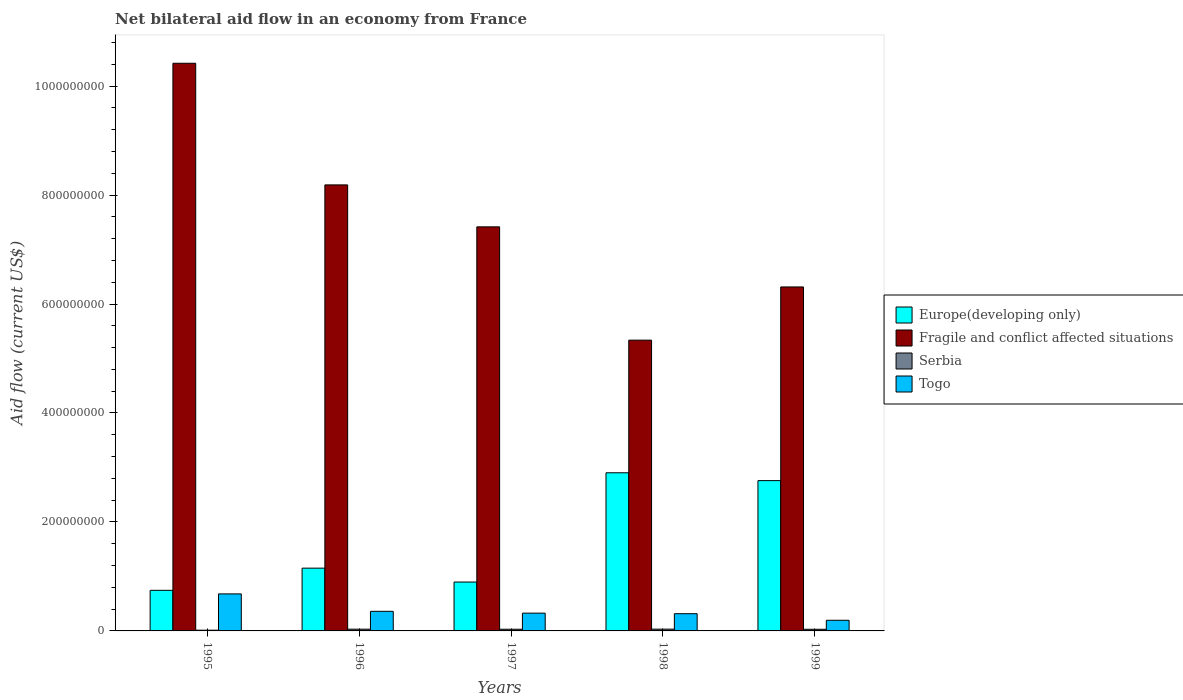How many different coloured bars are there?
Provide a short and direct response. 4. How many groups of bars are there?
Your answer should be compact. 5. Are the number of bars per tick equal to the number of legend labels?
Your answer should be very brief. Yes. Are the number of bars on each tick of the X-axis equal?
Offer a terse response. Yes. How many bars are there on the 3rd tick from the right?
Make the answer very short. 4. What is the net bilateral aid flow in Europe(developing only) in 1998?
Keep it short and to the point. 2.90e+08. Across all years, what is the maximum net bilateral aid flow in Togo?
Provide a succinct answer. 6.80e+07. Across all years, what is the minimum net bilateral aid flow in Togo?
Provide a succinct answer. 1.95e+07. In which year was the net bilateral aid flow in Fragile and conflict affected situations maximum?
Give a very brief answer. 1995. What is the total net bilateral aid flow in Fragile and conflict affected situations in the graph?
Make the answer very short. 3.77e+09. What is the difference between the net bilateral aid flow in Serbia in 1995 and that in 1996?
Make the answer very short. -1.86e+06. What is the difference between the net bilateral aid flow in Togo in 1997 and the net bilateral aid flow in Serbia in 1995?
Provide a short and direct response. 3.13e+07. What is the average net bilateral aid flow in Fragile and conflict affected situations per year?
Offer a terse response. 7.53e+08. In the year 1998, what is the difference between the net bilateral aid flow in Serbia and net bilateral aid flow in Togo?
Offer a terse response. -2.84e+07. What is the ratio of the net bilateral aid flow in Fragile and conflict affected situations in 1996 to that in 1997?
Give a very brief answer. 1.1. What is the difference between the highest and the second highest net bilateral aid flow in Fragile and conflict affected situations?
Your answer should be very brief. 2.23e+08. What is the difference between the highest and the lowest net bilateral aid flow in Serbia?
Offer a terse response. 1.91e+06. Is the sum of the net bilateral aid flow in Europe(developing only) in 1997 and 1999 greater than the maximum net bilateral aid flow in Serbia across all years?
Your response must be concise. Yes. Is it the case that in every year, the sum of the net bilateral aid flow in Fragile and conflict affected situations and net bilateral aid flow in Togo is greater than the sum of net bilateral aid flow in Europe(developing only) and net bilateral aid flow in Serbia?
Keep it short and to the point. Yes. What does the 3rd bar from the left in 1999 represents?
Keep it short and to the point. Serbia. What does the 4th bar from the right in 1999 represents?
Provide a short and direct response. Europe(developing only). Are all the bars in the graph horizontal?
Give a very brief answer. No. What is the difference between two consecutive major ticks on the Y-axis?
Give a very brief answer. 2.00e+08. How are the legend labels stacked?
Ensure brevity in your answer.  Vertical. What is the title of the graph?
Provide a short and direct response. Net bilateral aid flow in an economy from France. What is the Aid flow (current US$) of Europe(developing only) in 1995?
Your answer should be very brief. 7.45e+07. What is the Aid flow (current US$) in Fragile and conflict affected situations in 1995?
Keep it short and to the point. 1.04e+09. What is the Aid flow (current US$) of Serbia in 1995?
Keep it short and to the point. 1.33e+06. What is the Aid flow (current US$) of Togo in 1995?
Make the answer very short. 6.80e+07. What is the Aid flow (current US$) in Europe(developing only) in 1996?
Make the answer very short. 1.15e+08. What is the Aid flow (current US$) of Fragile and conflict affected situations in 1996?
Give a very brief answer. 8.19e+08. What is the Aid flow (current US$) of Serbia in 1996?
Ensure brevity in your answer.  3.19e+06. What is the Aid flow (current US$) in Togo in 1996?
Provide a succinct answer. 3.60e+07. What is the Aid flow (current US$) of Europe(developing only) in 1997?
Your answer should be compact. 8.97e+07. What is the Aid flow (current US$) in Fragile and conflict affected situations in 1997?
Provide a succinct answer. 7.42e+08. What is the Aid flow (current US$) of Serbia in 1997?
Give a very brief answer. 3.08e+06. What is the Aid flow (current US$) of Togo in 1997?
Give a very brief answer. 3.26e+07. What is the Aid flow (current US$) in Europe(developing only) in 1998?
Your answer should be compact. 2.90e+08. What is the Aid flow (current US$) of Fragile and conflict affected situations in 1998?
Give a very brief answer. 5.34e+08. What is the Aid flow (current US$) of Serbia in 1998?
Offer a terse response. 3.24e+06. What is the Aid flow (current US$) of Togo in 1998?
Your answer should be compact. 3.16e+07. What is the Aid flow (current US$) in Europe(developing only) in 1999?
Give a very brief answer. 2.76e+08. What is the Aid flow (current US$) in Fragile and conflict affected situations in 1999?
Offer a very short reply. 6.31e+08. What is the Aid flow (current US$) in Serbia in 1999?
Offer a terse response. 3.01e+06. What is the Aid flow (current US$) in Togo in 1999?
Offer a very short reply. 1.95e+07. Across all years, what is the maximum Aid flow (current US$) of Europe(developing only)?
Your answer should be very brief. 2.90e+08. Across all years, what is the maximum Aid flow (current US$) of Fragile and conflict affected situations?
Make the answer very short. 1.04e+09. Across all years, what is the maximum Aid flow (current US$) of Serbia?
Keep it short and to the point. 3.24e+06. Across all years, what is the maximum Aid flow (current US$) in Togo?
Provide a short and direct response. 6.80e+07. Across all years, what is the minimum Aid flow (current US$) in Europe(developing only)?
Offer a terse response. 7.45e+07. Across all years, what is the minimum Aid flow (current US$) in Fragile and conflict affected situations?
Make the answer very short. 5.34e+08. Across all years, what is the minimum Aid flow (current US$) in Serbia?
Offer a very short reply. 1.33e+06. Across all years, what is the minimum Aid flow (current US$) in Togo?
Make the answer very short. 1.95e+07. What is the total Aid flow (current US$) of Europe(developing only) in the graph?
Your answer should be compact. 8.46e+08. What is the total Aid flow (current US$) in Fragile and conflict affected situations in the graph?
Provide a short and direct response. 3.77e+09. What is the total Aid flow (current US$) of Serbia in the graph?
Offer a terse response. 1.38e+07. What is the total Aid flow (current US$) in Togo in the graph?
Your answer should be very brief. 1.88e+08. What is the difference between the Aid flow (current US$) in Europe(developing only) in 1995 and that in 1996?
Your answer should be compact. -4.07e+07. What is the difference between the Aid flow (current US$) in Fragile and conflict affected situations in 1995 and that in 1996?
Your response must be concise. 2.23e+08. What is the difference between the Aid flow (current US$) in Serbia in 1995 and that in 1996?
Keep it short and to the point. -1.86e+06. What is the difference between the Aid flow (current US$) of Togo in 1995 and that in 1996?
Make the answer very short. 3.20e+07. What is the difference between the Aid flow (current US$) in Europe(developing only) in 1995 and that in 1997?
Make the answer very short. -1.52e+07. What is the difference between the Aid flow (current US$) in Fragile and conflict affected situations in 1995 and that in 1997?
Give a very brief answer. 3.00e+08. What is the difference between the Aid flow (current US$) in Serbia in 1995 and that in 1997?
Ensure brevity in your answer.  -1.75e+06. What is the difference between the Aid flow (current US$) in Togo in 1995 and that in 1997?
Ensure brevity in your answer.  3.53e+07. What is the difference between the Aid flow (current US$) in Europe(developing only) in 1995 and that in 1998?
Provide a succinct answer. -2.16e+08. What is the difference between the Aid flow (current US$) of Fragile and conflict affected situations in 1995 and that in 1998?
Offer a very short reply. 5.08e+08. What is the difference between the Aid flow (current US$) of Serbia in 1995 and that in 1998?
Provide a short and direct response. -1.91e+06. What is the difference between the Aid flow (current US$) in Togo in 1995 and that in 1998?
Your answer should be very brief. 3.63e+07. What is the difference between the Aid flow (current US$) of Europe(developing only) in 1995 and that in 1999?
Provide a succinct answer. -2.01e+08. What is the difference between the Aid flow (current US$) in Fragile and conflict affected situations in 1995 and that in 1999?
Offer a terse response. 4.11e+08. What is the difference between the Aid flow (current US$) of Serbia in 1995 and that in 1999?
Ensure brevity in your answer.  -1.68e+06. What is the difference between the Aid flow (current US$) of Togo in 1995 and that in 1999?
Your answer should be very brief. 4.84e+07. What is the difference between the Aid flow (current US$) of Europe(developing only) in 1996 and that in 1997?
Offer a very short reply. 2.55e+07. What is the difference between the Aid flow (current US$) of Fragile and conflict affected situations in 1996 and that in 1997?
Your answer should be compact. 7.70e+07. What is the difference between the Aid flow (current US$) in Togo in 1996 and that in 1997?
Give a very brief answer. 3.35e+06. What is the difference between the Aid flow (current US$) of Europe(developing only) in 1996 and that in 1998?
Ensure brevity in your answer.  -1.75e+08. What is the difference between the Aid flow (current US$) of Fragile and conflict affected situations in 1996 and that in 1998?
Offer a terse response. 2.85e+08. What is the difference between the Aid flow (current US$) of Serbia in 1996 and that in 1998?
Offer a very short reply. -5.00e+04. What is the difference between the Aid flow (current US$) of Togo in 1996 and that in 1998?
Offer a very short reply. 4.36e+06. What is the difference between the Aid flow (current US$) in Europe(developing only) in 1996 and that in 1999?
Keep it short and to the point. -1.61e+08. What is the difference between the Aid flow (current US$) in Fragile and conflict affected situations in 1996 and that in 1999?
Your response must be concise. 1.87e+08. What is the difference between the Aid flow (current US$) in Togo in 1996 and that in 1999?
Make the answer very short. 1.64e+07. What is the difference between the Aid flow (current US$) in Europe(developing only) in 1997 and that in 1998?
Provide a short and direct response. -2.01e+08. What is the difference between the Aid flow (current US$) in Fragile and conflict affected situations in 1997 and that in 1998?
Give a very brief answer. 2.08e+08. What is the difference between the Aid flow (current US$) in Serbia in 1997 and that in 1998?
Provide a short and direct response. -1.60e+05. What is the difference between the Aid flow (current US$) of Togo in 1997 and that in 1998?
Provide a short and direct response. 1.01e+06. What is the difference between the Aid flow (current US$) of Europe(developing only) in 1997 and that in 1999?
Provide a succinct answer. -1.86e+08. What is the difference between the Aid flow (current US$) of Fragile and conflict affected situations in 1997 and that in 1999?
Offer a very short reply. 1.10e+08. What is the difference between the Aid flow (current US$) in Serbia in 1997 and that in 1999?
Offer a very short reply. 7.00e+04. What is the difference between the Aid flow (current US$) in Togo in 1997 and that in 1999?
Make the answer very short. 1.31e+07. What is the difference between the Aid flow (current US$) in Europe(developing only) in 1998 and that in 1999?
Ensure brevity in your answer.  1.44e+07. What is the difference between the Aid flow (current US$) of Fragile and conflict affected situations in 1998 and that in 1999?
Keep it short and to the point. -9.77e+07. What is the difference between the Aid flow (current US$) of Togo in 1998 and that in 1999?
Ensure brevity in your answer.  1.21e+07. What is the difference between the Aid flow (current US$) in Europe(developing only) in 1995 and the Aid flow (current US$) in Fragile and conflict affected situations in 1996?
Your answer should be very brief. -7.44e+08. What is the difference between the Aid flow (current US$) of Europe(developing only) in 1995 and the Aid flow (current US$) of Serbia in 1996?
Provide a short and direct response. 7.13e+07. What is the difference between the Aid flow (current US$) of Europe(developing only) in 1995 and the Aid flow (current US$) of Togo in 1996?
Give a very brief answer. 3.85e+07. What is the difference between the Aid flow (current US$) in Fragile and conflict affected situations in 1995 and the Aid flow (current US$) in Serbia in 1996?
Make the answer very short. 1.04e+09. What is the difference between the Aid flow (current US$) of Fragile and conflict affected situations in 1995 and the Aid flow (current US$) of Togo in 1996?
Offer a very short reply. 1.01e+09. What is the difference between the Aid flow (current US$) of Serbia in 1995 and the Aid flow (current US$) of Togo in 1996?
Your answer should be very brief. -3.46e+07. What is the difference between the Aid flow (current US$) of Europe(developing only) in 1995 and the Aid flow (current US$) of Fragile and conflict affected situations in 1997?
Your answer should be compact. -6.67e+08. What is the difference between the Aid flow (current US$) of Europe(developing only) in 1995 and the Aid flow (current US$) of Serbia in 1997?
Ensure brevity in your answer.  7.14e+07. What is the difference between the Aid flow (current US$) in Europe(developing only) in 1995 and the Aid flow (current US$) in Togo in 1997?
Give a very brief answer. 4.19e+07. What is the difference between the Aid flow (current US$) of Fragile and conflict affected situations in 1995 and the Aid flow (current US$) of Serbia in 1997?
Keep it short and to the point. 1.04e+09. What is the difference between the Aid flow (current US$) in Fragile and conflict affected situations in 1995 and the Aid flow (current US$) in Togo in 1997?
Provide a succinct answer. 1.01e+09. What is the difference between the Aid flow (current US$) in Serbia in 1995 and the Aid flow (current US$) in Togo in 1997?
Provide a succinct answer. -3.13e+07. What is the difference between the Aid flow (current US$) in Europe(developing only) in 1995 and the Aid flow (current US$) in Fragile and conflict affected situations in 1998?
Offer a terse response. -4.59e+08. What is the difference between the Aid flow (current US$) in Europe(developing only) in 1995 and the Aid flow (current US$) in Serbia in 1998?
Your response must be concise. 7.13e+07. What is the difference between the Aid flow (current US$) of Europe(developing only) in 1995 and the Aid flow (current US$) of Togo in 1998?
Make the answer very short. 4.29e+07. What is the difference between the Aid flow (current US$) of Fragile and conflict affected situations in 1995 and the Aid flow (current US$) of Serbia in 1998?
Your answer should be very brief. 1.04e+09. What is the difference between the Aid flow (current US$) of Fragile and conflict affected situations in 1995 and the Aid flow (current US$) of Togo in 1998?
Your answer should be very brief. 1.01e+09. What is the difference between the Aid flow (current US$) in Serbia in 1995 and the Aid flow (current US$) in Togo in 1998?
Make the answer very short. -3.03e+07. What is the difference between the Aid flow (current US$) in Europe(developing only) in 1995 and the Aid flow (current US$) in Fragile and conflict affected situations in 1999?
Give a very brief answer. -5.57e+08. What is the difference between the Aid flow (current US$) in Europe(developing only) in 1995 and the Aid flow (current US$) in Serbia in 1999?
Offer a very short reply. 7.15e+07. What is the difference between the Aid flow (current US$) in Europe(developing only) in 1995 and the Aid flow (current US$) in Togo in 1999?
Offer a very short reply. 5.50e+07. What is the difference between the Aid flow (current US$) in Fragile and conflict affected situations in 1995 and the Aid flow (current US$) in Serbia in 1999?
Provide a succinct answer. 1.04e+09. What is the difference between the Aid flow (current US$) of Fragile and conflict affected situations in 1995 and the Aid flow (current US$) of Togo in 1999?
Offer a terse response. 1.02e+09. What is the difference between the Aid flow (current US$) of Serbia in 1995 and the Aid flow (current US$) of Togo in 1999?
Make the answer very short. -1.82e+07. What is the difference between the Aid flow (current US$) in Europe(developing only) in 1996 and the Aid flow (current US$) in Fragile and conflict affected situations in 1997?
Provide a succinct answer. -6.26e+08. What is the difference between the Aid flow (current US$) of Europe(developing only) in 1996 and the Aid flow (current US$) of Serbia in 1997?
Offer a terse response. 1.12e+08. What is the difference between the Aid flow (current US$) of Europe(developing only) in 1996 and the Aid flow (current US$) of Togo in 1997?
Offer a terse response. 8.26e+07. What is the difference between the Aid flow (current US$) of Fragile and conflict affected situations in 1996 and the Aid flow (current US$) of Serbia in 1997?
Offer a terse response. 8.16e+08. What is the difference between the Aid flow (current US$) of Fragile and conflict affected situations in 1996 and the Aid flow (current US$) of Togo in 1997?
Keep it short and to the point. 7.86e+08. What is the difference between the Aid flow (current US$) of Serbia in 1996 and the Aid flow (current US$) of Togo in 1997?
Offer a terse response. -2.94e+07. What is the difference between the Aid flow (current US$) in Europe(developing only) in 1996 and the Aid flow (current US$) in Fragile and conflict affected situations in 1998?
Your response must be concise. -4.18e+08. What is the difference between the Aid flow (current US$) in Europe(developing only) in 1996 and the Aid flow (current US$) in Serbia in 1998?
Offer a terse response. 1.12e+08. What is the difference between the Aid flow (current US$) in Europe(developing only) in 1996 and the Aid flow (current US$) in Togo in 1998?
Your response must be concise. 8.36e+07. What is the difference between the Aid flow (current US$) of Fragile and conflict affected situations in 1996 and the Aid flow (current US$) of Serbia in 1998?
Your answer should be compact. 8.15e+08. What is the difference between the Aid flow (current US$) of Fragile and conflict affected situations in 1996 and the Aid flow (current US$) of Togo in 1998?
Keep it short and to the point. 7.87e+08. What is the difference between the Aid flow (current US$) of Serbia in 1996 and the Aid flow (current US$) of Togo in 1998?
Your response must be concise. -2.84e+07. What is the difference between the Aid flow (current US$) in Europe(developing only) in 1996 and the Aid flow (current US$) in Fragile and conflict affected situations in 1999?
Offer a terse response. -5.16e+08. What is the difference between the Aid flow (current US$) of Europe(developing only) in 1996 and the Aid flow (current US$) of Serbia in 1999?
Provide a short and direct response. 1.12e+08. What is the difference between the Aid flow (current US$) of Europe(developing only) in 1996 and the Aid flow (current US$) of Togo in 1999?
Your answer should be very brief. 9.57e+07. What is the difference between the Aid flow (current US$) of Fragile and conflict affected situations in 1996 and the Aid flow (current US$) of Serbia in 1999?
Keep it short and to the point. 8.16e+08. What is the difference between the Aid flow (current US$) in Fragile and conflict affected situations in 1996 and the Aid flow (current US$) in Togo in 1999?
Offer a very short reply. 7.99e+08. What is the difference between the Aid flow (current US$) of Serbia in 1996 and the Aid flow (current US$) of Togo in 1999?
Your answer should be compact. -1.64e+07. What is the difference between the Aid flow (current US$) of Europe(developing only) in 1997 and the Aid flow (current US$) of Fragile and conflict affected situations in 1998?
Make the answer very short. -4.44e+08. What is the difference between the Aid flow (current US$) of Europe(developing only) in 1997 and the Aid flow (current US$) of Serbia in 1998?
Ensure brevity in your answer.  8.65e+07. What is the difference between the Aid flow (current US$) of Europe(developing only) in 1997 and the Aid flow (current US$) of Togo in 1998?
Provide a short and direct response. 5.81e+07. What is the difference between the Aid flow (current US$) of Fragile and conflict affected situations in 1997 and the Aid flow (current US$) of Serbia in 1998?
Your answer should be very brief. 7.38e+08. What is the difference between the Aid flow (current US$) of Fragile and conflict affected situations in 1997 and the Aid flow (current US$) of Togo in 1998?
Make the answer very short. 7.10e+08. What is the difference between the Aid flow (current US$) in Serbia in 1997 and the Aid flow (current US$) in Togo in 1998?
Offer a very short reply. -2.85e+07. What is the difference between the Aid flow (current US$) in Europe(developing only) in 1997 and the Aid flow (current US$) in Fragile and conflict affected situations in 1999?
Your response must be concise. -5.42e+08. What is the difference between the Aid flow (current US$) of Europe(developing only) in 1997 and the Aid flow (current US$) of Serbia in 1999?
Offer a terse response. 8.67e+07. What is the difference between the Aid flow (current US$) of Europe(developing only) in 1997 and the Aid flow (current US$) of Togo in 1999?
Offer a terse response. 7.02e+07. What is the difference between the Aid flow (current US$) of Fragile and conflict affected situations in 1997 and the Aid flow (current US$) of Serbia in 1999?
Make the answer very short. 7.39e+08. What is the difference between the Aid flow (current US$) in Fragile and conflict affected situations in 1997 and the Aid flow (current US$) in Togo in 1999?
Make the answer very short. 7.22e+08. What is the difference between the Aid flow (current US$) in Serbia in 1997 and the Aid flow (current US$) in Togo in 1999?
Keep it short and to the point. -1.65e+07. What is the difference between the Aid flow (current US$) in Europe(developing only) in 1998 and the Aid flow (current US$) in Fragile and conflict affected situations in 1999?
Ensure brevity in your answer.  -3.41e+08. What is the difference between the Aid flow (current US$) of Europe(developing only) in 1998 and the Aid flow (current US$) of Serbia in 1999?
Give a very brief answer. 2.87e+08. What is the difference between the Aid flow (current US$) of Europe(developing only) in 1998 and the Aid flow (current US$) of Togo in 1999?
Make the answer very short. 2.71e+08. What is the difference between the Aid flow (current US$) of Fragile and conflict affected situations in 1998 and the Aid flow (current US$) of Serbia in 1999?
Make the answer very short. 5.31e+08. What is the difference between the Aid flow (current US$) of Fragile and conflict affected situations in 1998 and the Aid flow (current US$) of Togo in 1999?
Keep it short and to the point. 5.14e+08. What is the difference between the Aid flow (current US$) in Serbia in 1998 and the Aid flow (current US$) in Togo in 1999?
Keep it short and to the point. -1.63e+07. What is the average Aid flow (current US$) in Europe(developing only) per year?
Give a very brief answer. 1.69e+08. What is the average Aid flow (current US$) of Fragile and conflict affected situations per year?
Offer a very short reply. 7.53e+08. What is the average Aid flow (current US$) of Serbia per year?
Your response must be concise. 2.77e+06. What is the average Aid flow (current US$) of Togo per year?
Your response must be concise. 3.75e+07. In the year 1995, what is the difference between the Aid flow (current US$) in Europe(developing only) and Aid flow (current US$) in Fragile and conflict affected situations?
Your response must be concise. -9.67e+08. In the year 1995, what is the difference between the Aid flow (current US$) of Europe(developing only) and Aid flow (current US$) of Serbia?
Provide a short and direct response. 7.32e+07. In the year 1995, what is the difference between the Aid flow (current US$) of Europe(developing only) and Aid flow (current US$) of Togo?
Provide a succinct answer. 6.56e+06. In the year 1995, what is the difference between the Aid flow (current US$) of Fragile and conflict affected situations and Aid flow (current US$) of Serbia?
Offer a terse response. 1.04e+09. In the year 1995, what is the difference between the Aid flow (current US$) of Fragile and conflict affected situations and Aid flow (current US$) of Togo?
Offer a terse response. 9.74e+08. In the year 1995, what is the difference between the Aid flow (current US$) of Serbia and Aid flow (current US$) of Togo?
Your answer should be compact. -6.66e+07. In the year 1996, what is the difference between the Aid flow (current US$) in Europe(developing only) and Aid flow (current US$) in Fragile and conflict affected situations?
Offer a terse response. -7.03e+08. In the year 1996, what is the difference between the Aid flow (current US$) of Europe(developing only) and Aid flow (current US$) of Serbia?
Provide a short and direct response. 1.12e+08. In the year 1996, what is the difference between the Aid flow (current US$) of Europe(developing only) and Aid flow (current US$) of Togo?
Provide a short and direct response. 7.92e+07. In the year 1996, what is the difference between the Aid flow (current US$) in Fragile and conflict affected situations and Aid flow (current US$) in Serbia?
Provide a short and direct response. 8.15e+08. In the year 1996, what is the difference between the Aid flow (current US$) of Fragile and conflict affected situations and Aid flow (current US$) of Togo?
Give a very brief answer. 7.83e+08. In the year 1996, what is the difference between the Aid flow (current US$) of Serbia and Aid flow (current US$) of Togo?
Make the answer very short. -3.28e+07. In the year 1997, what is the difference between the Aid flow (current US$) of Europe(developing only) and Aid flow (current US$) of Fragile and conflict affected situations?
Your response must be concise. -6.52e+08. In the year 1997, what is the difference between the Aid flow (current US$) of Europe(developing only) and Aid flow (current US$) of Serbia?
Make the answer very short. 8.66e+07. In the year 1997, what is the difference between the Aid flow (current US$) in Europe(developing only) and Aid flow (current US$) in Togo?
Give a very brief answer. 5.71e+07. In the year 1997, what is the difference between the Aid flow (current US$) of Fragile and conflict affected situations and Aid flow (current US$) of Serbia?
Offer a very short reply. 7.39e+08. In the year 1997, what is the difference between the Aid flow (current US$) in Fragile and conflict affected situations and Aid flow (current US$) in Togo?
Your answer should be very brief. 7.09e+08. In the year 1997, what is the difference between the Aid flow (current US$) of Serbia and Aid flow (current US$) of Togo?
Your response must be concise. -2.96e+07. In the year 1998, what is the difference between the Aid flow (current US$) of Europe(developing only) and Aid flow (current US$) of Fragile and conflict affected situations?
Make the answer very short. -2.43e+08. In the year 1998, what is the difference between the Aid flow (current US$) of Europe(developing only) and Aid flow (current US$) of Serbia?
Give a very brief answer. 2.87e+08. In the year 1998, what is the difference between the Aid flow (current US$) of Europe(developing only) and Aid flow (current US$) of Togo?
Give a very brief answer. 2.59e+08. In the year 1998, what is the difference between the Aid flow (current US$) in Fragile and conflict affected situations and Aid flow (current US$) in Serbia?
Offer a very short reply. 5.30e+08. In the year 1998, what is the difference between the Aid flow (current US$) of Fragile and conflict affected situations and Aid flow (current US$) of Togo?
Make the answer very short. 5.02e+08. In the year 1998, what is the difference between the Aid flow (current US$) of Serbia and Aid flow (current US$) of Togo?
Provide a succinct answer. -2.84e+07. In the year 1999, what is the difference between the Aid flow (current US$) in Europe(developing only) and Aid flow (current US$) in Fragile and conflict affected situations?
Keep it short and to the point. -3.55e+08. In the year 1999, what is the difference between the Aid flow (current US$) in Europe(developing only) and Aid flow (current US$) in Serbia?
Provide a short and direct response. 2.73e+08. In the year 1999, what is the difference between the Aid flow (current US$) of Europe(developing only) and Aid flow (current US$) of Togo?
Ensure brevity in your answer.  2.56e+08. In the year 1999, what is the difference between the Aid flow (current US$) of Fragile and conflict affected situations and Aid flow (current US$) of Serbia?
Provide a short and direct response. 6.28e+08. In the year 1999, what is the difference between the Aid flow (current US$) of Fragile and conflict affected situations and Aid flow (current US$) of Togo?
Ensure brevity in your answer.  6.12e+08. In the year 1999, what is the difference between the Aid flow (current US$) in Serbia and Aid flow (current US$) in Togo?
Your answer should be very brief. -1.65e+07. What is the ratio of the Aid flow (current US$) in Europe(developing only) in 1995 to that in 1996?
Keep it short and to the point. 0.65. What is the ratio of the Aid flow (current US$) in Fragile and conflict affected situations in 1995 to that in 1996?
Keep it short and to the point. 1.27. What is the ratio of the Aid flow (current US$) of Serbia in 1995 to that in 1996?
Provide a succinct answer. 0.42. What is the ratio of the Aid flow (current US$) of Togo in 1995 to that in 1996?
Your response must be concise. 1.89. What is the ratio of the Aid flow (current US$) of Europe(developing only) in 1995 to that in 1997?
Your answer should be very brief. 0.83. What is the ratio of the Aid flow (current US$) of Fragile and conflict affected situations in 1995 to that in 1997?
Ensure brevity in your answer.  1.4. What is the ratio of the Aid flow (current US$) in Serbia in 1995 to that in 1997?
Offer a very short reply. 0.43. What is the ratio of the Aid flow (current US$) in Togo in 1995 to that in 1997?
Offer a very short reply. 2.08. What is the ratio of the Aid flow (current US$) of Europe(developing only) in 1995 to that in 1998?
Your answer should be compact. 0.26. What is the ratio of the Aid flow (current US$) in Fragile and conflict affected situations in 1995 to that in 1998?
Keep it short and to the point. 1.95. What is the ratio of the Aid flow (current US$) in Serbia in 1995 to that in 1998?
Make the answer very short. 0.41. What is the ratio of the Aid flow (current US$) of Togo in 1995 to that in 1998?
Your answer should be very brief. 2.15. What is the ratio of the Aid flow (current US$) in Europe(developing only) in 1995 to that in 1999?
Provide a short and direct response. 0.27. What is the ratio of the Aid flow (current US$) in Fragile and conflict affected situations in 1995 to that in 1999?
Provide a succinct answer. 1.65. What is the ratio of the Aid flow (current US$) of Serbia in 1995 to that in 1999?
Offer a terse response. 0.44. What is the ratio of the Aid flow (current US$) of Togo in 1995 to that in 1999?
Provide a succinct answer. 3.48. What is the ratio of the Aid flow (current US$) of Europe(developing only) in 1996 to that in 1997?
Keep it short and to the point. 1.28. What is the ratio of the Aid flow (current US$) in Fragile and conflict affected situations in 1996 to that in 1997?
Your answer should be very brief. 1.1. What is the ratio of the Aid flow (current US$) of Serbia in 1996 to that in 1997?
Provide a succinct answer. 1.04. What is the ratio of the Aid flow (current US$) of Togo in 1996 to that in 1997?
Provide a succinct answer. 1.1. What is the ratio of the Aid flow (current US$) of Europe(developing only) in 1996 to that in 1998?
Give a very brief answer. 0.4. What is the ratio of the Aid flow (current US$) of Fragile and conflict affected situations in 1996 to that in 1998?
Make the answer very short. 1.53. What is the ratio of the Aid flow (current US$) in Serbia in 1996 to that in 1998?
Provide a succinct answer. 0.98. What is the ratio of the Aid flow (current US$) of Togo in 1996 to that in 1998?
Your response must be concise. 1.14. What is the ratio of the Aid flow (current US$) of Europe(developing only) in 1996 to that in 1999?
Offer a very short reply. 0.42. What is the ratio of the Aid flow (current US$) in Fragile and conflict affected situations in 1996 to that in 1999?
Your answer should be very brief. 1.3. What is the ratio of the Aid flow (current US$) of Serbia in 1996 to that in 1999?
Ensure brevity in your answer.  1.06. What is the ratio of the Aid flow (current US$) in Togo in 1996 to that in 1999?
Make the answer very short. 1.84. What is the ratio of the Aid flow (current US$) in Europe(developing only) in 1997 to that in 1998?
Your answer should be compact. 0.31. What is the ratio of the Aid flow (current US$) in Fragile and conflict affected situations in 1997 to that in 1998?
Your answer should be very brief. 1.39. What is the ratio of the Aid flow (current US$) of Serbia in 1997 to that in 1998?
Make the answer very short. 0.95. What is the ratio of the Aid flow (current US$) of Togo in 1997 to that in 1998?
Give a very brief answer. 1.03. What is the ratio of the Aid flow (current US$) of Europe(developing only) in 1997 to that in 1999?
Provide a succinct answer. 0.33. What is the ratio of the Aid flow (current US$) in Fragile and conflict affected situations in 1997 to that in 1999?
Your response must be concise. 1.17. What is the ratio of the Aid flow (current US$) of Serbia in 1997 to that in 1999?
Offer a very short reply. 1.02. What is the ratio of the Aid flow (current US$) in Togo in 1997 to that in 1999?
Your response must be concise. 1.67. What is the ratio of the Aid flow (current US$) of Europe(developing only) in 1998 to that in 1999?
Ensure brevity in your answer.  1.05. What is the ratio of the Aid flow (current US$) of Fragile and conflict affected situations in 1998 to that in 1999?
Offer a terse response. 0.85. What is the ratio of the Aid flow (current US$) in Serbia in 1998 to that in 1999?
Offer a very short reply. 1.08. What is the ratio of the Aid flow (current US$) of Togo in 1998 to that in 1999?
Your response must be concise. 1.62. What is the difference between the highest and the second highest Aid flow (current US$) in Europe(developing only)?
Your answer should be compact. 1.44e+07. What is the difference between the highest and the second highest Aid flow (current US$) of Fragile and conflict affected situations?
Provide a succinct answer. 2.23e+08. What is the difference between the highest and the second highest Aid flow (current US$) in Serbia?
Your answer should be compact. 5.00e+04. What is the difference between the highest and the second highest Aid flow (current US$) of Togo?
Keep it short and to the point. 3.20e+07. What is the difference between the highest and the lowest Aid flow (current US$) of Europe(developing only)?
Offer a very short reply. 2.16e+08. What is the difference between the highest and the lowest Aid flow (current US$) of Fragile and conflict affected situations?
Offer a very short reply. 5.08e+08. What is the difference between the highest and the lowest Aid flow (current US$) in Serbia?
Ensure brevity in your answer.  1.91e+06. What is the difference between the highest and the lowest Aid flow (current US$) of Togo?
Make the answer very short. 4.84e+07. 